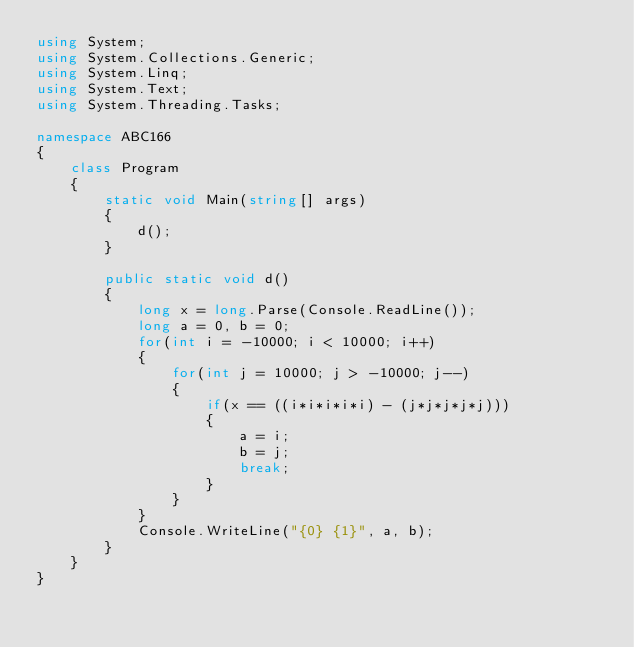<code> <loc_0><loc_0><loc_500><loc_500><_C#_>using System;
using System.Collections.Generic;
using System.Linq;
using System.Text;
using System.Threading.Tasks;

namespace ABC166
{
    class Program
    {
        static void Main(string[] args)
        {
            d();
        }

        public static void d()
        {
            long x = long.Parse(Console.ReadLine());
            long a = 0, b = 0;
            for(int i = -10000; i < 10000; i++)
            {
                for(int j = 10000; j > -10000; j--)
                {
                    if(x == ((i*i*i*i*i) - (j*j*j*j*j)))
                    {
                        a = i;
                        b = j;
                        break;
                    }
                }
            }
            Console.WriteLine("{0} {1}", a, b);
        }
    }
}
</code> 